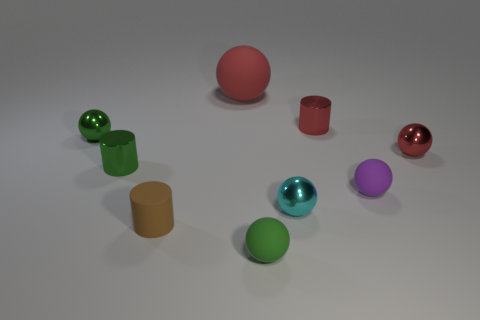Subtract all green spheres. How many spheres are left? 4 Subtract all red cylinders. How many cylinders are left? 2 Subtract all blue cubes. How many red balls are left? 2 Subtract 2 spheres. How many spheres are left? 4 Subtract all purple balls. Subtract all purple cylinders. How many balls are left? 5 Subtract all cylinders. How many objects are left? 6 Add 1 purple rubber spheres. How many purple rubber spheres exist? 2 Subtract 0 blue cylinders. How many objects are left? 9 Subtract all small gray cubes. Subtract all small red spheres. How many objects are left? 8 Add 3 red metal objects. How many red metal objects are left? 5 